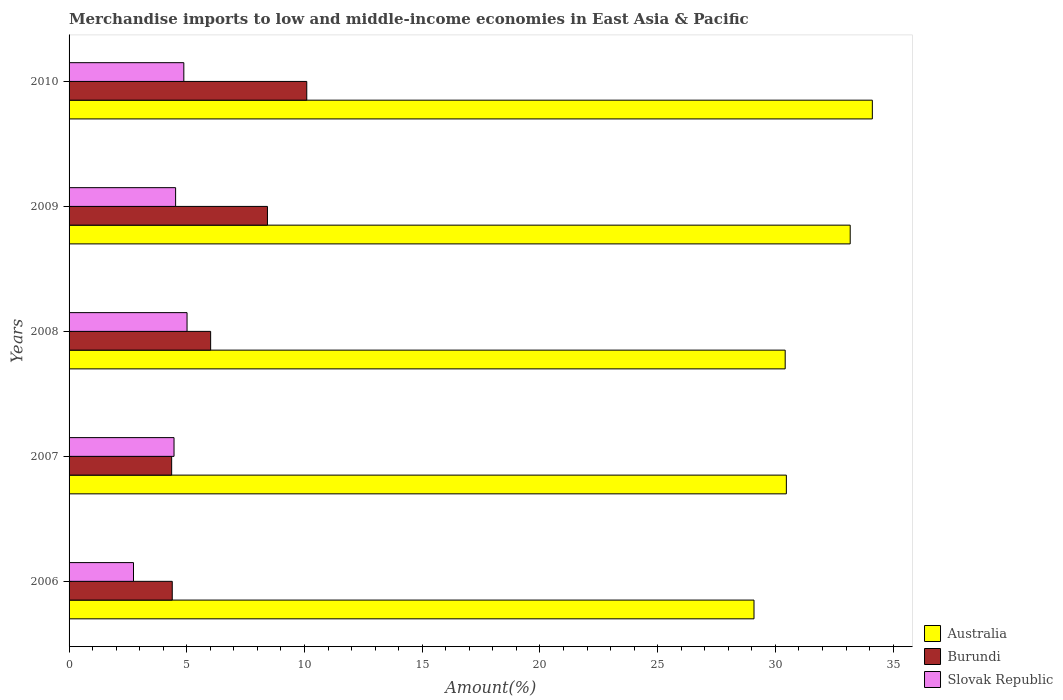How many bars are there on the 3rd tick from the top?
Your response must be concise. 3. How many bars are there on the 2nd tick from the bottom?
Keep it short and to the point. 3. What is the label of the 1st group of bars from the top?
Give a very brief answer. 2010. What is the percentage of amount earned from merchandise imports in Australia in 2008?
Offer a very short reply. 30.42. Across all years, what is the maximum percentage of amount earned from merchandise imports in Slovak Republic?
Your response must be concise. 5.01. Across all years, what is the minimum percentage of amount earned from merchandise imports in Slovak Republic?
Offer a terse response. 2.74. What is the total percentage of amount earned from merchandise imports in Burundi in the graph?
Provide a short and direct response. 33.28. What is the difference between the percentage of amount earned from merchandise imports in Slovak Republic in 2006 and that in 2010?
Offer a very short reply. -2.14. What is the difference between the percentage of amount earned from merchandise imports in Slovak Republic in 2009 and the percentage of amount earned from merchandise imports in Australia in 2008?
Your answer should be very brief. -25.89. What is the average percentage of amount earned from merchandise imports in Slovak Republic per year?
Your response must be concise. 4.32. In the year 2007, what is the difference between the percentage of amount earned from merchandise imports in Burundi and percentage of amount earned from merchandise imports in Australia?
Your response must be concise. -26.11. In how many years, is the percentage of amount earned from merchandise imports in Burundi greater than 9 %?
Offer a very short reply. 1. What is the ratio of the percentage of amount earned from merchandise imports in Burundi in 2006 to that in 2009?
Your answer should be very brief. 0.52. What is the difference between the highest and the second highest percentage of amount earned from merchandise imports in Australia?
Give a very brief answer. 0.94. What is the difference between the highest and the lowest percentage of amount earned from merchandise imports in Australia?
Keep it short and to the point. 5.03. In how many years, is the percentage of amount earned from merchandise imports in Australia greater than the average percentage of amount earned from merchandise imports in Australia taken over all years?
Provide a succinct answer. 2. Is the sum of the percentage of amount earned from merchandise imports in Burundi in 2006 and 2007 greater than the maximum percentage of amount earned from merchandise imports in Slovak Republic across all years?
Provide a short and direct response. Yes. What does the 1st bar from the top in 2010 represents?
Give a very brief answer. Slovak Republic. What does the 2nd bar from the bottom in 2006 represents?
Offer a terse response. Burundi. Are all the bars in the graph horizontal?
Keep it short and to the point. Yes. How many years are there in the graph?
Keep it short and to the point. 5. Where does the legend appear in the graph?
Your response must be concise. Bottom right. How many legend labels are there?
Make the answer very short. 3. How are the legend labels stacked?
Offer a terse response. Vertical. What is the title of the graph?
Provide a succinct answer. Merchandise imports to low and middle-income economies in East Asia & Pacific. Does "Burkina Faso" appear as one of the legend labels in the graph?
Provide a succinct answer. No. What is the label or title of the X-axis?
Make the answer very short. Amount(%). What is the label or title of the Y-axis?
Provide a short and direct response. Years. What is the Amount(%) of Australia in 2006?
Ensure brevity in your answer.  29.09. What is the Amount(%) in Burundi in 2006?
Your answer should be compact. 4.38. What is the Amount(%) in Slovak Republic in 2006?
Keep it short and to the point. 2.74. What is the Amount(%) in Australia in 2007?
Provide a short and direct response. 30.47. What is the Amount(%) in Burundi in 2007?
Make the answer very short. 4.36. What is the Amount(%) in Slovak Republic in 2007?
Offer a terse response. 4.46. What is the Amount(%) of Australia in 2008?
Ensure brevity in your answer.  30.42. What is the Amount(%) of Burundi in 2008?
Offer a very short reply. 6.01. What is the Amount(%) of Slovak Republic in 2008?
Give a very brief answer. 5.01. What is the Amount(%) in Australia in 2009?
Your response must be concise. 33.18. What is the Amount(%) in Burundi in 2009?
Provide a succinct answer. 8.43. What is the Amount(%) in Slovak Republic in 2009?
Your answer should be very brief. 4.52. What is the Amount(%) of Australia in 2010?
Your answer should be compact. 34.12. What is the Amount(%) in Burundi in 2010?
Your answer should be compact. 10.1. What is the Amount(%) of Slovak Republic in 2010?
Keep it short and to the point. 4.87. Across all years, what is the maximum Amount(%) of Australia?
Offer a very short reply. 34.12. Across all years, what is the maximum Amount(%) of Burundi?
Provide a succinct answer. 10.1. Across all years, what is the maximum Amount(%) of Slovak Republic?
Your response must be concise. 5.01. Across all years, what is the minimum Amount(%) in Australia?
Your response must be concise. 29.09. Across all years, what is the minimum Amount(%) of Burundi?
Your response must be concise. 4.36. Across all years, what is the minimum Amount(%) of Slovak Republic?
Ensure brevity in your answer.  2.74. What is the total Amount(%) in Australia in the graph?
Keep it short and to the point. 157.27. What is the total Amount(%) in Burundi in the graph?
Your answer should be compact. 33.28. What is the total Amount(%) of Slovak Republic in the graph?
Provide a short and direct response. 21.61. What is the difference between the Amount(%) of Australia in 2006 and that in 2007?
Provide a short and direct response. -1.37. What is the difference between the Amount(%) in Burundi in 2006 and that in 2007?
Ensure brevity in your answer.  0.03. What is the difference between the Amount(%) of Slovak Republic in 2006 and that in 2007?
Ensure brevity in your answer.  -1.72. What is the difference between the Amount(%) in Australia in 2006 and that in 2008?
Your answer should be compact. -1.32. What is the difference between the Amount(%) in Burundi in 2006 and that in 2008?
Provide a short and direct response. -1.63. What is the difference between the Amount(%) in Slovak Republic in 2006 and that in 2008?
Provide a short and direct response. -2.27. What is the difference between the Amount(%) of Australia in 2006 and that in 2009?
Provide a succinct answer. -4.09. What is the difference between the Amount(%) in Burundi in 2006 and that in 2009?
Ensure brevity in your answer.  -4.04. What is the difference between the Amount(%) in Slovak Republic in 2006 and that in 2009?
Ensure brevity in your answer.  -1.79. What is the difference between the Amount(%) of Australia in 2006 and that in 2010?
Your response must be concise. -5.03. What is the difference between the Amount(%) in Burundi in 2006 and that in 2010?
Give a very brief answer. -5.71. What is the difference between the Amount(%) of Slovak Republic in 2006 and that in 2010?
Ensure brevity in your answer.  -2.14. What is the difference between the Amount(%) of Australia in 2007 and that in 2008?
Provide a succinct answer. 0.05. What is the difference between the Amount(%) of Burundi in 2007 and that in 2008?
Provide a short and direct response. -1.66. What is the difference between the Amount(%) in Slovak Republic in 2007 and that in 2008?
Your response must be concise. -0.55. What is the difference between the Amount(%) in Australia in 2007 and that in 2009?
Make the answer very short. -2.71. What is the difference between the Amount(%) in Burundi in 2007 and that in 2009?
Ensure brevity in your answer.  -4.07. What is the difference between the Amount(%) of Slovak Republic in 2007 and that in 2009?
Your response must be concise. -0.07. What is the difference between the Amount(%) of Australia in 2007 and that in 2010?
Your answer should be very brief. -3.65. What is the difference between the Amount(%) of Burundi in 2007 and that in 2010?
Your answer should be very brief. -5.74. What is the difference between the Amount(%) in Slovak Republic in 2007 and that in 2010?
Ensure brevity in your answer.  -0.42. What is the difference between the Amount(%) of Australia in 2008 and that in 2009?
Your answer should be compact. -2.76. What is the difference between the Amount(%) in Burundi in 2008 and that in 2009?
Provide a succinct answer. -2.41. What is the difference between the Amount(%) of Slovak Republic in 2008 and that in 2009?
Keep it short and to the point. 0.49. What is the difference between the Amount(%) of Australia in 2008 and that in 2010?
Your response must be concise. -3.7. What is the difference between the Amount(%) of Burundi in 2008 and that in 2010?
Keep it short and to the point. -4.08. What is the difference between the Amount(%) of Slovak Republic in 2008 and that in 2010?
Your answer should be very brief. 0.14. What is the difference between the Amount(%) of Australia in 2009 and that in 2010?
Offer a terse response. -0.94. What is the difference between the Amount(%) of Burundi in 2009 and that in 2010?
Provide a short and direct response. -1.67. What is the difference between the Amount(%) in Slovak Republic in 2009 and that in 2010?
Ensure brevity in your answer.  -0.35. What is the difference between the Amount(%) of Australia in 2006 and the Amount(%) of Burundi in 2007?
Offer a terse response. 24.74. What is the difference between the Amount(%) of Australia in 2006 and the Amount(%) of Slovak Republic in 2007?
Your response must be concise. 24.63. What is the difference between the Amount(%) of Burundi in 2006 and the Amount(%) of Slovak Republic in 2007?
Your response must be concise. -0.08. What is the difference between the Amount(%) of Australia in 2006 and the Amount(%) of Burundi in 2008?
Your response must be concise. 23.08. What is the difference between the Amount(%) of Australia in 2006 and the Amount(%) of Slovak Republic in 2008?
Offer a very short reply. 24.08. What is the difference between the Amount(%) of Burundi in 2006 and the Amount(%) of Slovak Republic in 2008?
Give a very brief answer. -0.63. What is the difference between the Amount(%) of Australia in 2006 and the Amount(%) of Burundi in 2009?
Your answer should be compact. 20.67. What is the difference between the Amount(%) in Australia in 2006 and the Amount(%) in Slovak Republic in 2009?
Your answer should be compact. 24.57. What is the difference between the Amount(%) of Burundi in 2006 and the Amount(%) of Slovak Republic in 2009?
Provide a short and direct response. -0.14. What is the difference between the Amount(%) of Australia in 2006 and the Amount(%) of Burundi in 2010?
Give a very brief answer. 19. What is the difference between the Amount(%) in Australia in 2006 and the Amount(%) in Slovak Republic in 2010?
Offer a terse response. 24.22. What is the difference between the Amount(%) of Burundi in 2006 and the Amount(%) of Slovak Republic in 2010?
Provide a short and direct response. -0.49. What is the difference between the Amount(%) of Australia in 2007 and the Amount(%) of Burundi in 2008?
Keep it short and to the point. 24.45. What is the difference between the Amount(%) of Australia in 2007 and the Amount(%) of Slovak Republic in 2008?
Provide a short and direct response. 25.46. What is the difference between the Amount(%) in Burundi in 2007 and the Amount(%) in Slovak Republic in 2008?
Offer a terse response. -0.65. What is the difference between the Amount(%) of Australia in 2007 and the Amount(%) of Burundi in 2009?
Provide a succinct answer. 22.04. What is the difference between the Amount(%) in Australia in 2007 and the Amount(%) in Slovak Republic in 2009?
Provide a succinct answer. 25.94. What is the difference between the Amount(%) in Burundi in 2007 and the Amount(%) in Slovak Republic in 2009?
Make the answer very short. -0.17. What is the difference between the Amount(%) of Australia in 2007 and the Amount(%) of Burundi in 2010?
Give a very brief answer. 20.37. What is the difference between the Amount(%) of Australia in 2007 and the Amount(%) of Slovak Republic in 2010?
Provide a succinct answer. 25.59. What is the difference between the Amount(%) of Burundi in 2007 and the Amount(%) of Slovak Republic in 2010?
Offer a very short reply. -0.52. What is the difference between the Amount(%) of Australia in 2008 and the Amount(%) of Burundi in 2009?
Offer a terse response. 21.99. What is the difference between the Amount(%) in Australia in 2008 and the Amount(%) in Slovak Republic in 2009?
Ensure brevity in your answer.  25.89. What is the difference between the Amount(%) of Burundi in 2008 and the Amount(%) of Slovak Republic in 2009?
Make the answer very short. 1.49. What is the difference between the Amount(%) of Australia in 2008 and the Amount(%) of Burundi in 2010?
Make the answer very short. 20.32. What is the difference between the Amount(%) in Australia in 2008 and the Amount(%) in Slovak Republic in 2010?
Your answer should be compact. 25.54. What is the difference between the Amount(%) in Burundi in 2008 and the Amount(%) in Slovak Republic in 2010?
Provide a succinct answer. 1.14. What is the difference between the Amount(%) of Australia in 2009 and the Amount(%) of Burundi in 2010?
Give a very brief answer. 23.08. What is the difference between the Amount(%) of Australia in 2009 and the Amount(%) of Slovak Republic in 2010?
Give a very brief answer. 28.3. What is the difference between the Amount(%) in Burundi in 2009 and the Amount(%) in Slovak Republic in 2010?
Offer a terse response. 3.55. What is the average Amount(%) in Australia per year?
Ensure brevity in your answer.  31.45. What is the average Amount(%) of Burundi per year?
Make the answer very short. 6.66. What is the average Amount(%) in Slovak Republic per year?
Your answer should be compact. 4.32. In the year 2006, what is the difference between the Amount(%) of Australia and Amount(%) of Burundi?
Provide a succinct answer. 24.71. In the year 2006, what is the difference between the Amount(%) in Australia and Amount(%) in Slovak Republic?
Offer a very short reply. 26.36. In the year 2006, what is the difference between the Amount(%) in Burundi and Amount(%) in Slovak Republic?
Your answer should be compact. 1.65. In the year 2007, what is the difference between the Amount(%) in Australia and Amount(%) in Burundi?
Your answer should be very brief. 26.11. In the year 2007, what is the difference between the Amount(%) of Australia and Amount(%) of Slovak Republic?
Offer a very short reply. 26.01. In the year 2007, what is the difference between the Amount(%) of Burundi and Amount(%) of Slovak Republic?
Offer a very short reply. -0.1. In the year 2008, what is the difference between the Amount(%) in Australia and Amount(%) in Burundi?
Offer a very short reply. 24.4. In the year 2008, what is the difference between the Amount(%) of Australia and Amount(%) of Slovak Republic?
Keep it short and to the point. 25.41. In the year 2008, what is the difference between the Amount(%) in Burundi and Amount(%) in Slovak Republic?
Your answer should be compact. 1. In the year 2009, what is the difference between the Amount(%) in Australia and Amount(%) in Burundi?
Make the answer very short. 24.75. In the year 2009, what is the difference between the Amount(%) of Australia and Amount(%) of Slovak Republic?
Keep it short and to the point. 28.65. In the year 2009, what is the difference between the Amount(%) in Burundi and Amount(%) in Slovak Republic?
Keep it short and to the point. 3.9. In the year 2010, what is the difference between the Amount(%) in Australia and Amount(%) in Burundi?
Provide a succinct answer. 24.02. In the year 2010, what is the difference between the Amount(%) in Australia and Amount(%) in Slovak Republic?
Offer a terse response. 29.24. In the year 2010, what is the difference between the Amount(%) in Burundi and Amount(%) in Slovak Republic?
Make the answer very short. 5.22. What is the ratio of the Amount(%) in Australia in 2006 to that in 2007?
Provide a short and direct response. 0.95. What is the ratio of the Amount(%) of Burundi in 2006 to that in 2007?
Make the answer very short. 1.01. What is the ratio of the Amount(%) of Slovak Republic in 2006 to that in 2007?
Provide a short and direct response. 0.61. What is the ratio of the Amount(%) of Australia in 2006 to that in 2008?
Keep it short and to the point. 0.96. What is the ratio of the Amount(%) in Burundi in 2006 to that in 2008?
Your response must be concise. 0.73. What is the ratio of the Amount(%) of Slovak Republic in 2006 to that in 2008?
Your answer should be very brief. 0.55. What is the ratio of the Amount(%) of Australia in 2006 to that in 2009?
Offer a terse response. 0.88. What is the ratio of the Amount(%) in Burundi in 2006 to that in 2009?
Keep it short and to the point. 0.52. What is the ratio of the Amount(%) in Slovak Republic in 2006 to that in 2009?
Your response must be concise. 0.6. What is the ratio of the Amount(%) of Australia in 2006 to that in 2010?
Offer a very short reply. 0.85. What is the ratio of the Amount(%) of Burundi in 2006 to that in 2010?
Your answer should be very brief. 0.43. What is the ratio of the Amount(%) in Slovak Republic in 2006 to that in 2010?
Offer a terse response. 0.56. What is the ratio of the Amount(%) of Australia in 2007 to that in 2008?
Give a very brief answer. 1. What is the ratio of the Amount(%) in Burundi in 2007 to that in 2008?
Make the answer very short. 0.72. What is the ratio of the Amount(%) in Slovak Republic in 2007 to that in 2008?
Offer a very short reply. 0.89. What is the ratio of the Amount(%) in Australia in 2007 to that in 2009?
Ensure brevity in your answer.  0.92. What is the ratio of the Amount(%) in Burundi in 2007 to that in 2009?
Keep it short and to the point. 0.52. What is the ratio of the Amount(%) of Australia in 2007 to that in 2010?
Give a very brief answer. 0.89. What is the ratio of the Amount(%) of Burundi in 2007 to that in 2010?
Keep it short and to the point. 0.43. What is the ratio of the Amount(%) in Slovak Republic in 2007 to that in 2010?
Ensure brevity in your answer.  0.91. What is the ratio of the Amount(%) of Australia in 2008 to that in 2009?
Provide a succinct answer. 0.92. What is the ratio of the Amount(%) in Burundi in 2008 to that in 2009?
Your answer should be compact. 0.71. What is the ratio of the Amount(%) of Slovak Republic in 2008 to that in 2009?
Offer a terse response. 1.11. What is the ratio of the Amount(%) of Australia in 2008 to that in 2010?
Make the answer very short. 0.89. What is the ratio of the Amount(%) of Burundi in 2008 to that in 2010?
Offer a terse response. 0.6. What is the ratio of the Amount(%) of Slovak Republic in 2008 to that in 2010?
Your answer should be very brief. 1.03. What is the ratio of the Amount(%) of Australia in 2009 to that in 2010?
Provide a short and direct response. 0.97. What is the ratio of the Amount(%) in Burundi in 2009 to that in 2010?
Provide a short and direct response. 0.83. What is the ratio of the Amount(%) in Slovak Republic in 2009 to that in 2010?
Provide a short and direct response. 0.93. What is the difference between the highest and the second highest Amount(%) of Australia?
Give a very brief answer. 0.94. What is the difference between the highest and the second highest Amount(%) in Burundi?
Give a very brief answer. 1.67. What is the difference between the highest and the second highest Amount(%) in Slovak Republic?
Make the answer very short. 0.14. What is the difference between the highest and the lowest Amount(%) of Australia?
Your answer should be very brief. 5.03. What is the difference between the highest and the lowest Amount(%) of Burundi?
Give a very brief answer. 5.74. What is the difference between the highest and the lowest Amount(%) in Slovak Republic?
Offer a very short reply. 2.27. 